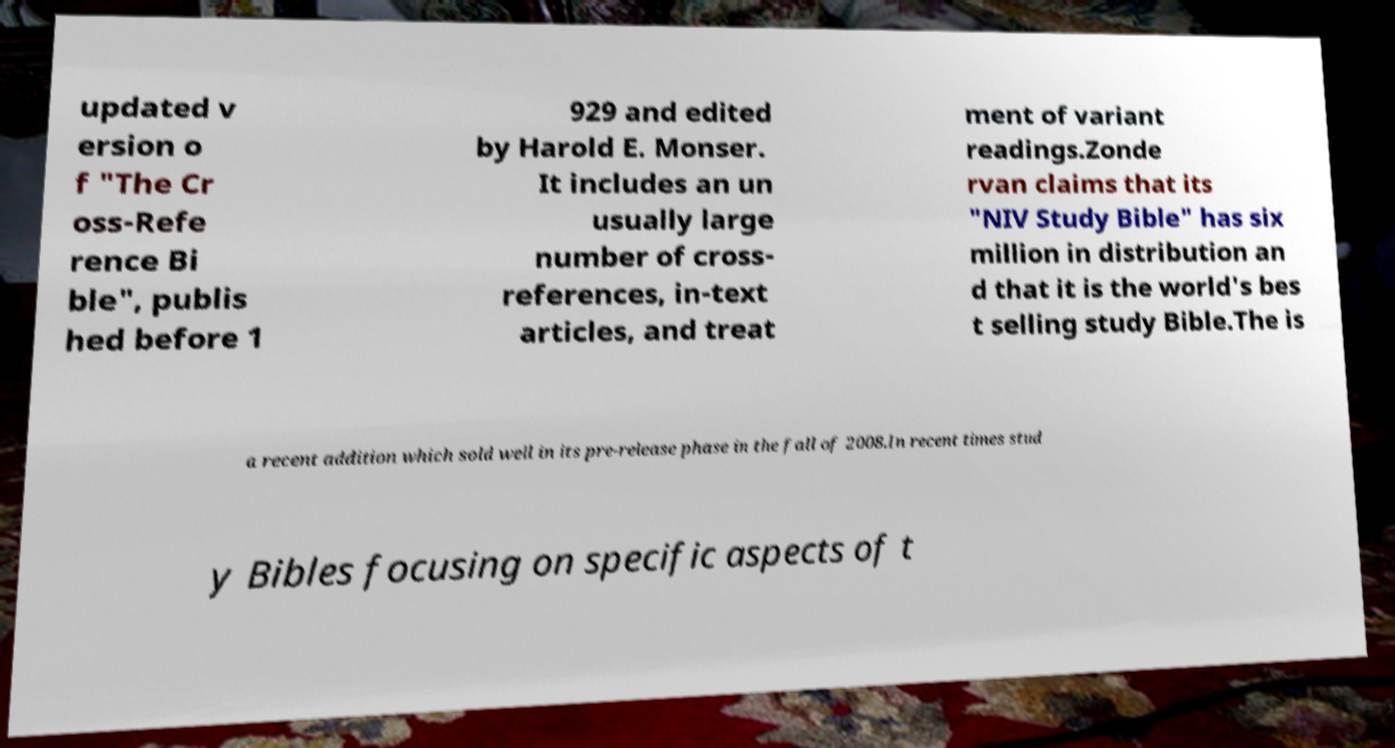Could you assist in decoding the text presented in this image and type it out clearly? updated v ersion o f "The Cr oss-Refe rence Bi ble", publis hed before 1 929 and edited by Harold E. Monser. It includes an un usually large number of cross- references, in-text articles, and treat ment of variant readings.Zonde rvan claims that its "NIV Study Bible" has six million in distribution an d that it is the world's bes t selling study Bible.The is a recent addition which sold well in its pre-release phase in the fall of 2008.In recent times stud y Bibles focusing on specific aspects of t 